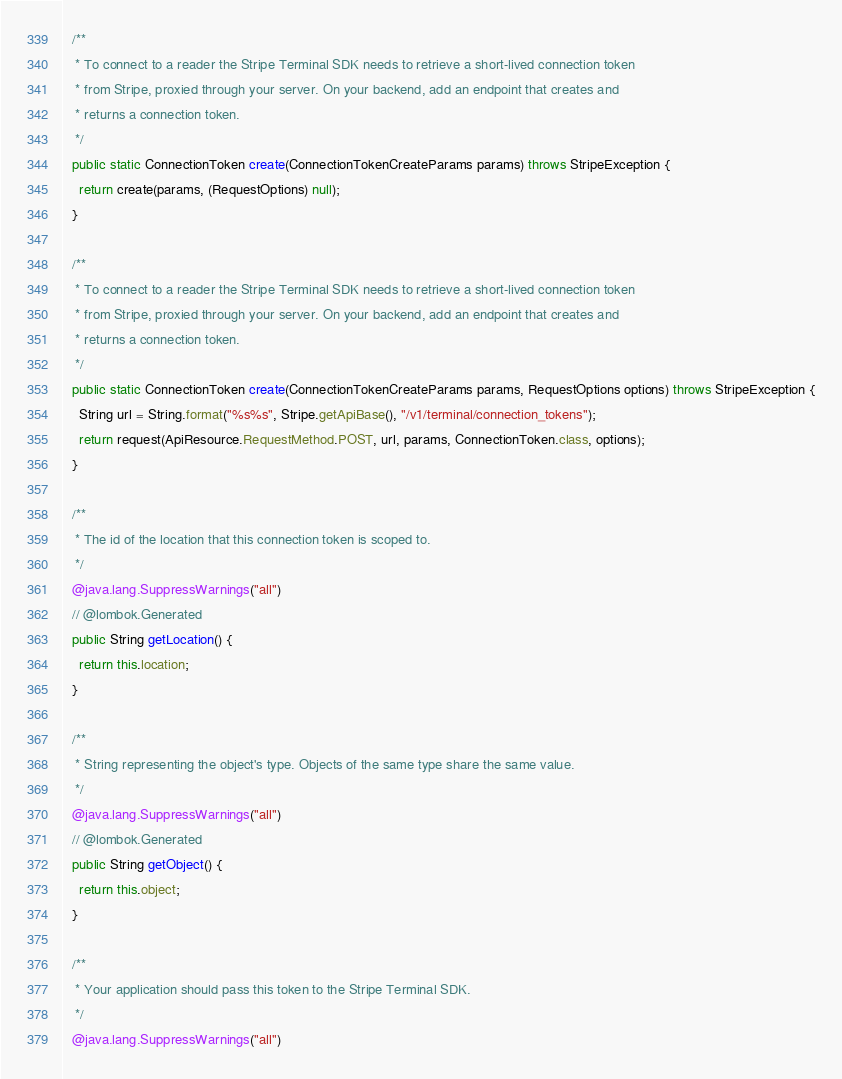Convert code to text. <code><loc_0><loc_0><loc_500><loc_500><_Java_>  /**
   * To connect to a reader the Stripe Terminal SDK needs to retrieve a short-lived connection token
   * from Stripe, proxied through your server. On your backend, add an endpoint that creates and
   * returns a connection token.
   */
  public static ConnectionToken create(ConnectionTokenCreateParams params) throws StripeException {
    return create(params, (RequestOptions) null);
  }

  /**
   * To connect to a reader the Stripe Terminal SDK needs to retrieve a short-lived connection token
   * from Stripe, proxied through your server. On your backend, add an endpoint that creates and
   * returns a connection token.
   */
  public static ConnectionToken create(ConnectionTokenCreateParams params, RequestOptions options) throws StripeException {
    String url = String.format("%s%s", Stripe.getApiBase(), "/v1/terminal/connection_tokens");
    return request(ApiResource.RequestMethod.POST, url, params, ConnectionToken.class, options);
  }

  /**
   * The id of the location that this connection token is scoped to.
   */
  @java.lang.SuppressWarnings("all")
  // @lombok.Generated
  public String getLocation() {
    return this.location;
  }

  /**
   * String representing the object's type. Objects of the same type share the same value.
   */
  @java.lang.SuppressWarnings("all")
  // @lombok.Generated
  public String getObject() {
    return this.object;
  }

  /**
   * Your application should pass this token to the Stripe Terminal SDK.
   */
  @java.lang.SuppressWarnings("all")</code> 